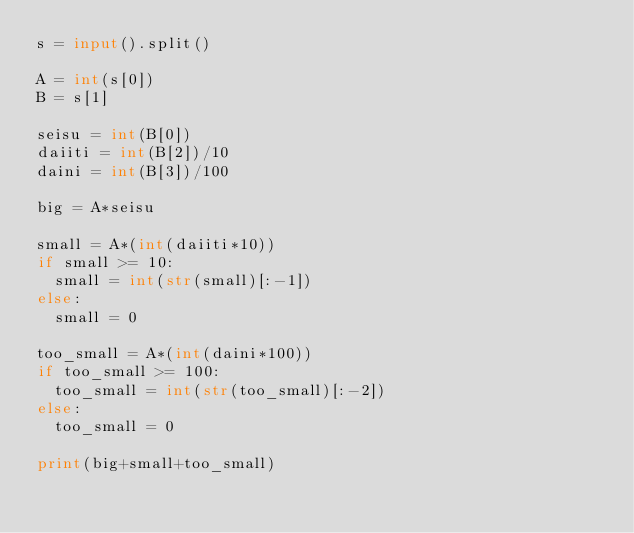Convert code to text. <code><loc_0><loc_0><loc_500><loc_500><_Python_>s = input().split()

A = int(s[0])
B = s[1]

seisu = int(B[0])
daiiti = int(B[2])/10
daini = int(B[3])/100

big = A*seisu

small = A*(int(daiiti*10))
if small >= 10:
  small = int(str(small)[:-1])
else:
  small = 0

too_small = A*(int(daini*100))
if too_small >= 100:
  too_small = int(str(too_small)[:-2])
else:
  too_small = 0

print(big+small+too_small)</code> 